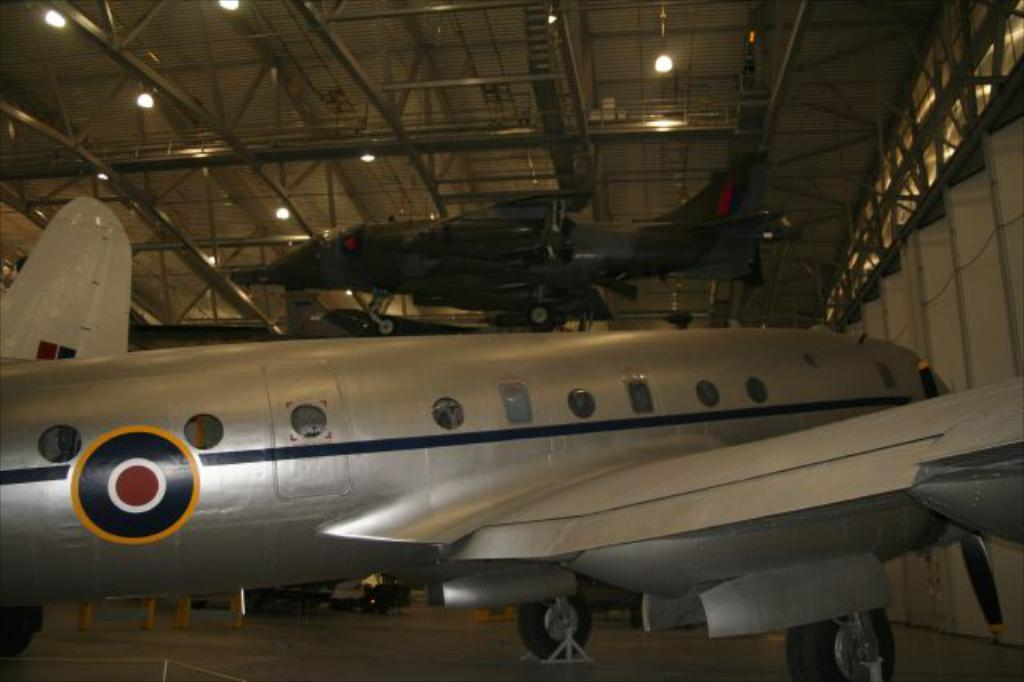What type of infrastructure is depicted in the image? There are airways in the image. What can be seen below the airways in the image? The ground is visible in the image. What is present on the ground in the image? There are objects on the ground. What type of structure can be seen in the image? There is a wall in the image. What additional structure is present in the image? There is a shed in the image. What feature can be observed on the shed? The shed has lights at the top. How does the nose feel the air in the image? There is no nose present in the image. 